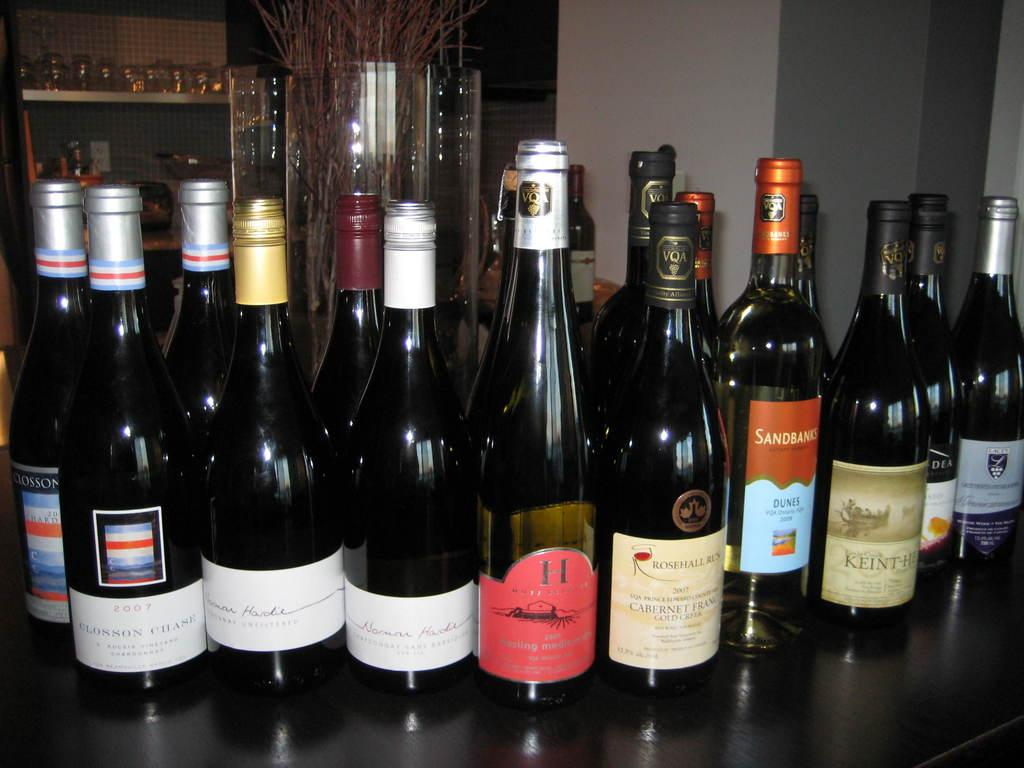<image>
Share a concise interpretation of the image provided. A large collection of wines from Sandbanks to many others sit on a table. 